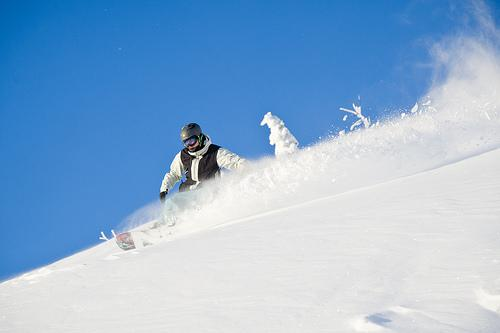Question: why is some snow spraying up into air?
Choices:
A. It is windy.
B. There is a storm.
C. A car drive by.
D. Person is skiing.
Answer with the letter. Answer: D Question: where is this scene located?
Choices:
A. Ski slope.
B. A beach.
C. A zoo.
D. A resort.
Answer with the letter. Answer: A Question: how does a person maneuver when skiing?
Choices:
A. Lean.
B. On skis.
C. Crouch.
D. Jump.
Answer with the letter. Answer: B 